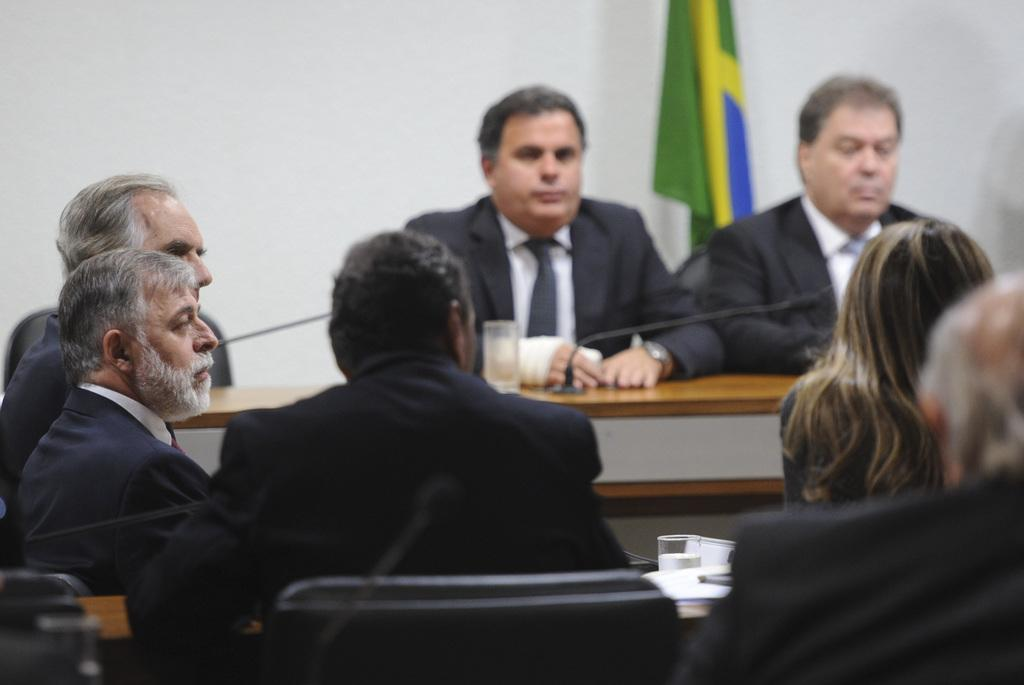What are the persons in the image wearing? The persons in the image are wearing black suits. What are the persons doing in the image? The persons are sitting in the image. What is in front of the persons? There is a table in front of the persons. What is on the table? There is a mic on the table. What type of pets are visible in the image? There are no pets visible in the image. How many heads of lettuce are on the table in the image? There is no lettuce present in the image. 